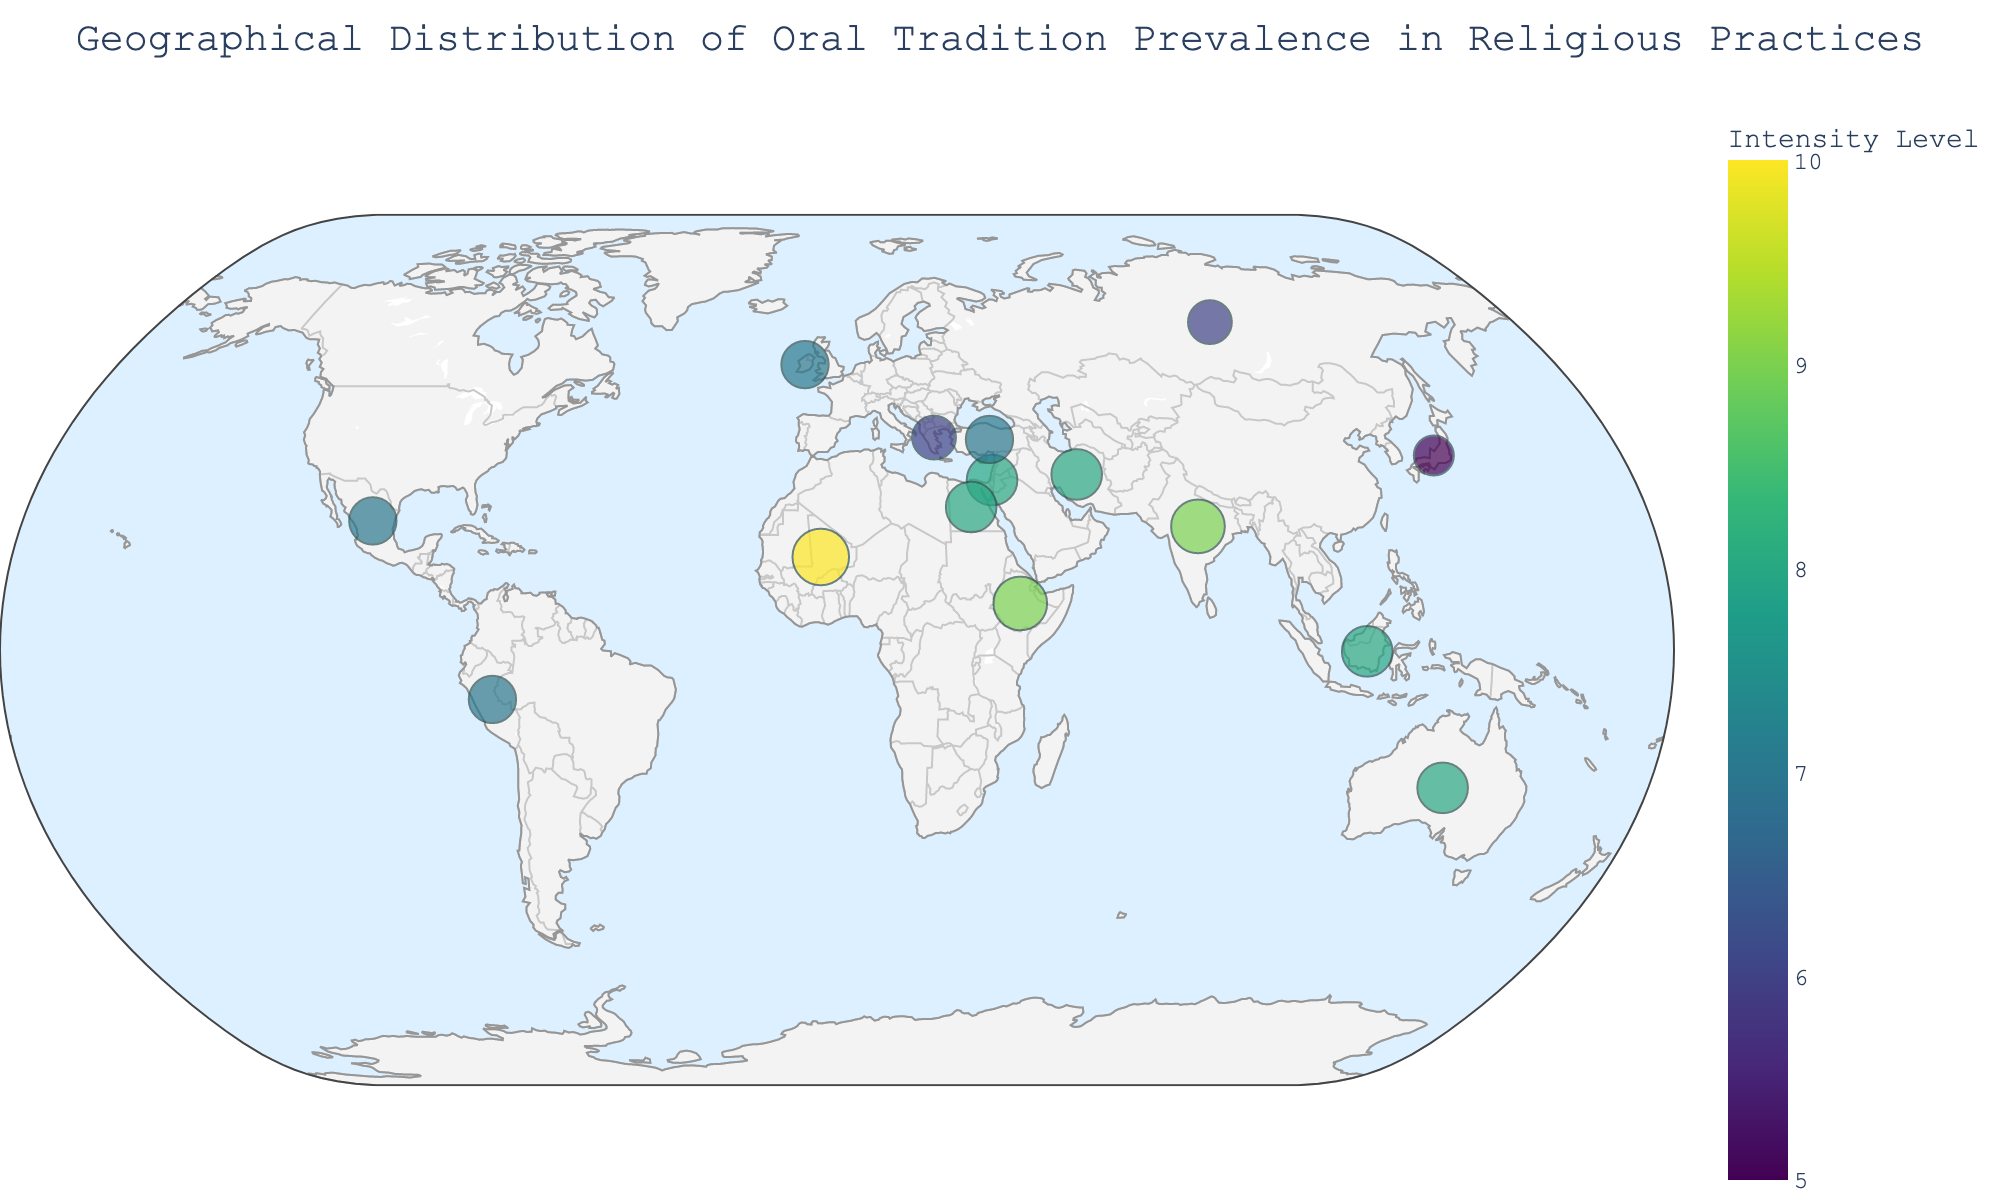What is the title of the plot? The title of the plot is displayed prominently at the top of the figure.
Answer: Geographical Distribution of Oral Tradition Prevalence in Religious Practices Which country shows the highest intensity of oral tradition in religious practices? The country with the highest intensity level is identified by looking for the largest circle in the plot with the darkest color.
Answer: Mali What is the average oral tradition intensity for the Middle East region? Sum the intensity levels of the countries in the Middle East (Israel, Iran, and Turkey) and divide by the number of countries: (8 + 8 + 7) / 3 = 7.67
Answer: 7.67 Compare the intensity levels of oral traditions between South Asia and Southeast Asia. Which region has higher average intensity? Calculate the average for each region. South Asia (India = 9), Southeast Asia (Indonesia = 8). South Asia has an average of 9, whereas Southeast Asia has an average of 8.
Answer: South Asia Which region is represented by the largest number of countries on the plot? Count the number of countries within each region.
Answer: Middle East How many countries have an intensity level of 8? Count the number of circles on the plot that have an intensity level of 8 by referring to the color scale.
Answer: 5 What is the intensity level of oral tradition in Japan? Find Japan on the plot and read the intensity value corresponding to its circle.
Answer: 5 Which country in North America is shown in the plot, and what is its intensity level? Identify the country in North America by its position on the plot and check the corresponding intensity level.
Answer: Mexico, 7 Compare the intensity levels of Ireland and Greece. Which country has a higher intensity? Locate both Ireland and Greece on the plot and compare the intensity values.
Answer: Ireland Is there any country in the Oceania region shown on the plot? If yes, what is its intensity level? Identify whether any countries from Oceania are present on the plot and check their intensity level.
Answer: Yes, Australia with an intensity of 8 